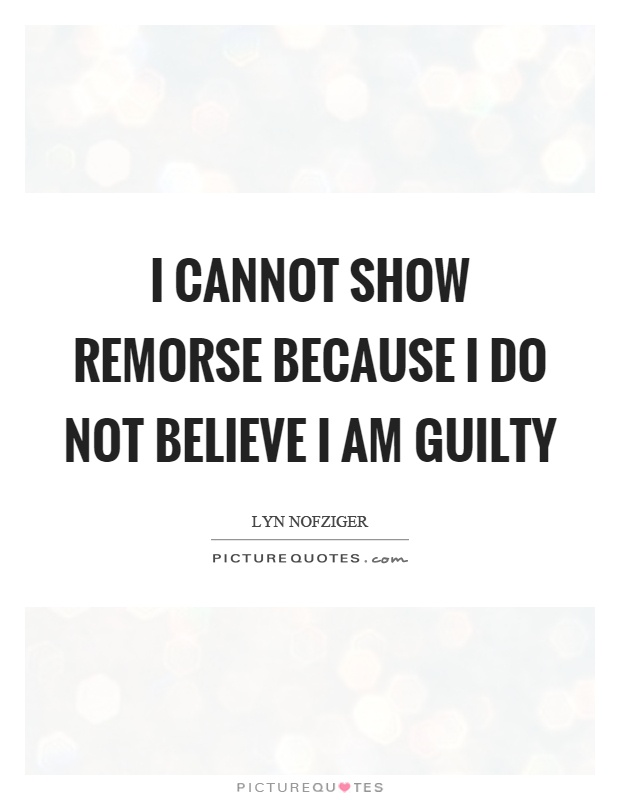Based on the style and presentation of the quote in the image, what can we infer about the intended audience or use of this image? The minimalistic design of the quote, using a clean, modern sans-serif font against a soft, unfocused bokeh background, is likely aimed at a contemporary audience who appreciates aesthetics that highlight the message without distraction. The overall design suggests an intent to evoke a thoughtful or introspective reaction, tailored for sharing across social platforms or personal blogs where users seek inspiration or philosophical insights. The use of a clearly professional yet subtle design implies that the creators intended this image for widespread dissemination, ideally within environments that value simplicity and contemplative messaging. 